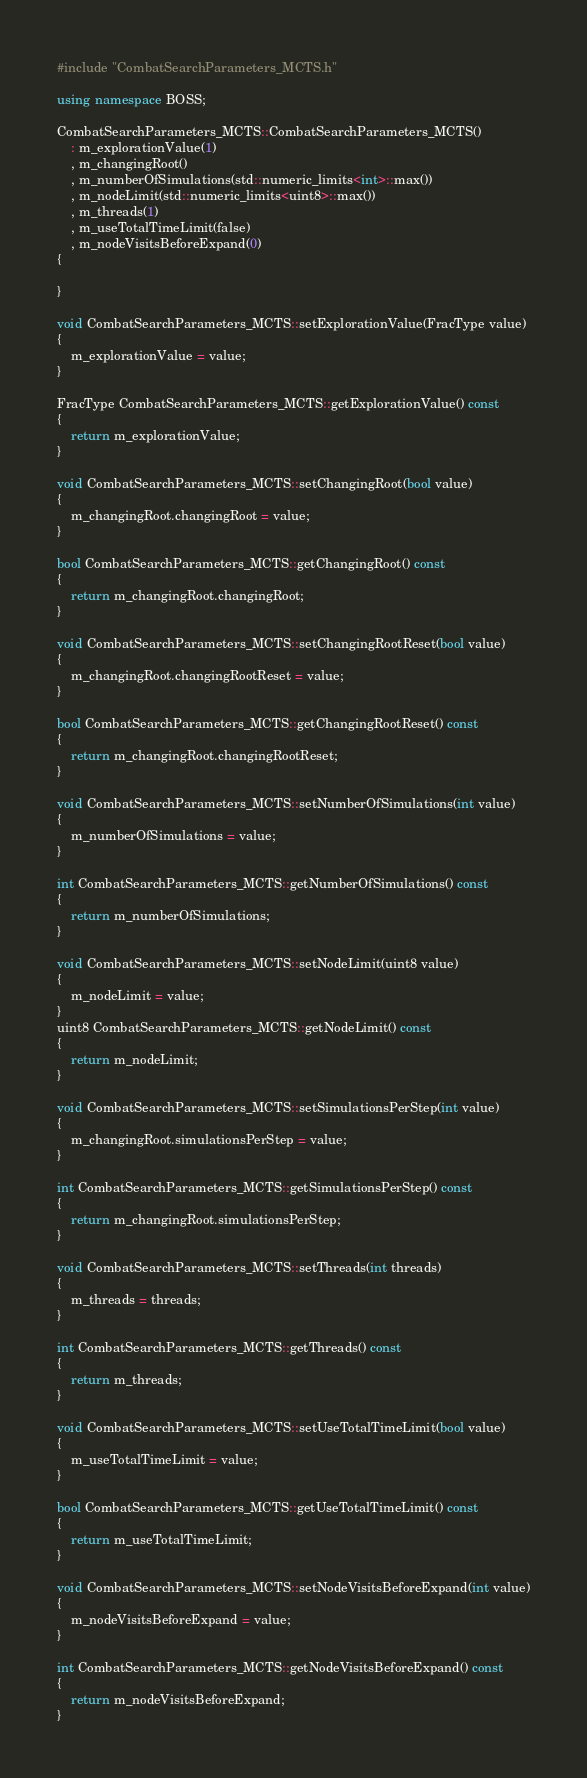<code> <loc_0><loc_0><loc_500><loc_500><_C++_>#include "CombatSearchParameters_MCTS.h"

using namespace BOSS;

CombatSearchParameters_MCTS::CombatSearchParameters_MCTS()
    : m_explorationValue(1)
    , m_changingRoot()
    , m_numberOfSimulations(std::numeric_limits<int>::max())
    , m_nodeLimit(std::numeric_limits<uint8>::max())
    , m_threads(1)
    , m_useTotalTimeLimit(false)
    , m_nodeVisitsBeforeExpand(0)
{

}

void CombatSearchParameters_MCTS::setExplorationValue(FracType value)
{
    m_explorationValue = value;
}

FracType CombatSearchParameters_MCTS::getExplorationValue() const
{
    return m_explorationValue;
}

void CombatSearchParameters_MCTS::setChangingRoot(bool value)
{
    m_changingRoot.changingRoot = value;
}

bool CombatSearchParameters_MCTS::getChangingRoot() const
{
    return m_changingRoot.changingRoot;
}

void CombatSearchParameters_MCTS::setChangingRootReset(bool value)
{
    m_changingRoot.changingRootReset = value;
}

bool CombatSearchParameters_MCTS::getChangingRootReset() const
{
    return m_changingRoot.changingRootReset;
}

void CombatSearchParameters_MCTS::setNumberOfSimulations(int value)
{
    m_numberOfSimulations = value;
}

int CombatSearchParameters_MCTS::getNumberOfSimulations() const
{
    return m_numberOfSimulations;
}

void CombatSearchParameters_MCTS::setNodeLimit(uint8 value)
{
    m_nodeLimit = value;
}
uint8 CombatSearchParameters_MCTS::getNodeLimit() const
{
    return m_nodeLimit;
}

void CombatSearchParameters_MCTS::setSimulationsPerStep(int value)
{
    m_changingRoot.simulationsPerStep = value;
}

int CombatSearchParameters_MCTS::getSimulationsPerStep() const
{
    return m_changingRoot.simulationsPerStep;
}

void CombatSearchParameters_MCTS::setThreads(int threads)
{
    m_threads = threads;
}

int CombatSearchParameters_MCTS::getThreads() const
{
    return m_threads;
}

void CombatSearchParameters_MCTS::setUseTotalTimeLimit(bool value)
{
    m_useTotalTimeLimit = value;
}

bool CombatSearchParameters_MCTS::getUseTotalTimeLimit() const
{
    return m_useTotalTimeLimit;
}

void CombatSearchParameters_MCTS::setNodeVisitsBeforeExpand(int value)
{
    m_nodeVisitsBeforeExpand = value;
}

int CombatSearchParameters_MCTS::getNodeVisitsBeforeExpand() const
{
    return m_nodeVisitsBeforeExpand;
}</code> 